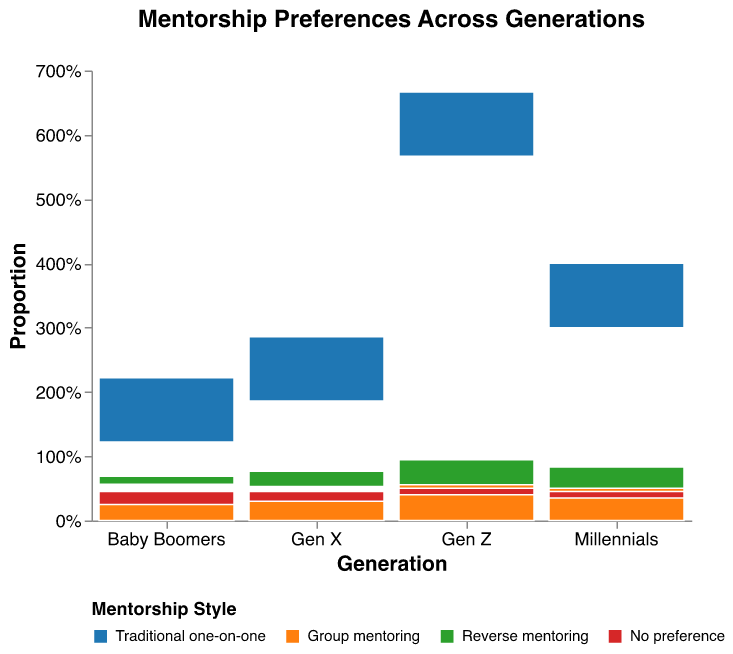What is the most preferred mentorship style for Baby Boomers? From the plot, the largest portion of the mosaic for Baby Boomers is colored in a light blue, which corresponds to the "Traditional one-on-one" mentorship style in the legend. This indicates the most preferred mentorship style for Baby Boomers is "Traditional one-on-one".
Answer: Traditional one-on-one Which generation prefers group mentoring the most? The plot shows a breakdown for each generation's preference, and Gen Z has the largest proportion of their section in orange, which stands for "Group mentoring".
Answer: Gen Z What percentage of Millennials prefer reverse mentoring? To find this, look at the green portion of the Millennials section. The length of the bar representing "Reverse mentoring" for Millennials indicates that around 30% of Millennials prefer reverse mentoring.
Answer: 30% Compare the no preference category between Baby Boomers and Millennials—who has a higher proportion? Look at the red portions of Baby Boomers and Millennials. The red portion for Baby Boomers appears larger than for Millennials, indicating Baby Boomers have a higher proportion with no preference.
Answer: Baby Boomers How does the proportion of Gen Z preferring traditional one-on-one mentoring compare with that of Gen X? The blue segment for "Traditional one-on-one" in Gen Z is significantly smaller than the one in Gen X, indicating that a smaller proportion of Gen Z prefers traditional one-on-one mentoring compared to Gen X.
Answer: Smaller What is the sum of the frequencies for "Group mentoring" and "Reverse mentoring" in Gen Z? Look at the frequencies given: "Group mentoring" for Gen Z is 40, and "Reverse mentoring" for Gen Z is 35. Adding these together gives 40 + 35 = 75.
Answer: 75 Which generation has the least interest in traditional one-on-one mentorship? The smallest blue portion among the generations is for Gen Z. This means Gen Z has the least interest in traditional one-on-one mentorship.
Answer: Gen Z If the data were combined, which mentorship style is preferred overall? By inspecting the plot, it's clear that "Group mentoring" (orange segments) appears frequently and constitutes a larger combined portion across generations. "Group mentoring" emerges as the overall preferred mentorship style.
Answer: Group mentoring Which mentorship style shows a general increasing preference among younger generations? The green portions (reverse mentoring) see a relative increase as we move from Baby Boomers to Gen Z, indicating this style of mentorship shows an increasing preference among younger generations.
Answer: Reverse mentoring Based on the figure, provide two significant insights about the differences in mentorship preferences between Baby Boomers and Gen Z. First, Baby Boomers have a strong preference for traditional one-on-one mentorship, while Gen Z shows a strong preference for group mentoring. Second, reverse mentoring is much more preferred by Gen Z compared to Baby Boomers.
Answer: Baby Boomers prefer traditional one-on-one, Gen Z prefers group mentoring; Reverse mentoring more preferred by Gen Z than Baby Boomers 